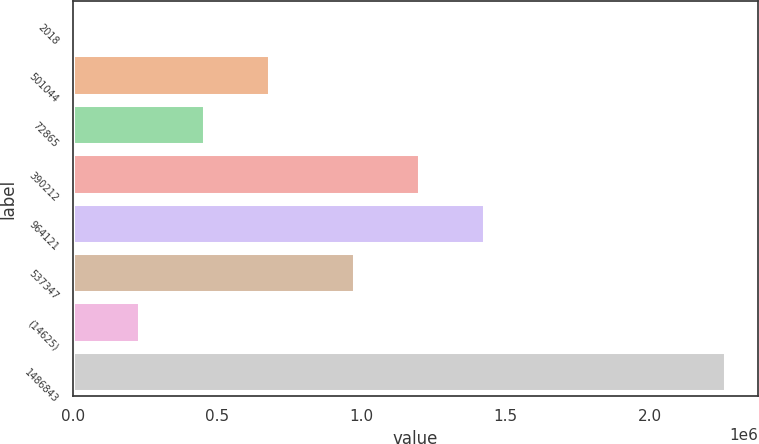Convert chart. <chart><loc_0><loc_0><loc_500><loc_500><bar_chart><fcel>2018<fcel>501044<fcel>72865<fcel>390212<fcel>964121<fcel>537347<fcel>(14625)<fcel>1486843<nl><fcel>2016<fcel>680153<fcel>454107<fcel>1.19949e+06<fcel>1.42554e+06<fcel>973446<fcel>228062<fcel>2.26247e+06<nl></chart> 